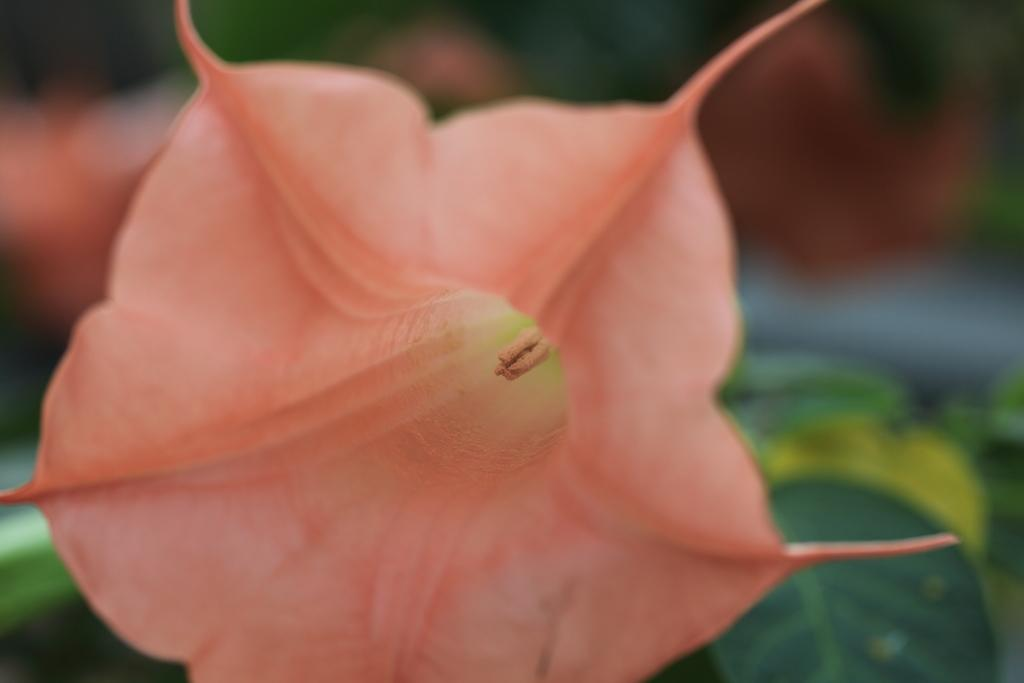What is the main subject of the image? There is a flower in the image. Can you describe the surroundings of the flower? There are other flowers and leaves in the background of the image. What type of meat can be seen hanging from the flower in the image? There is no meat present in the image; it features a flower and other plants in the background. 